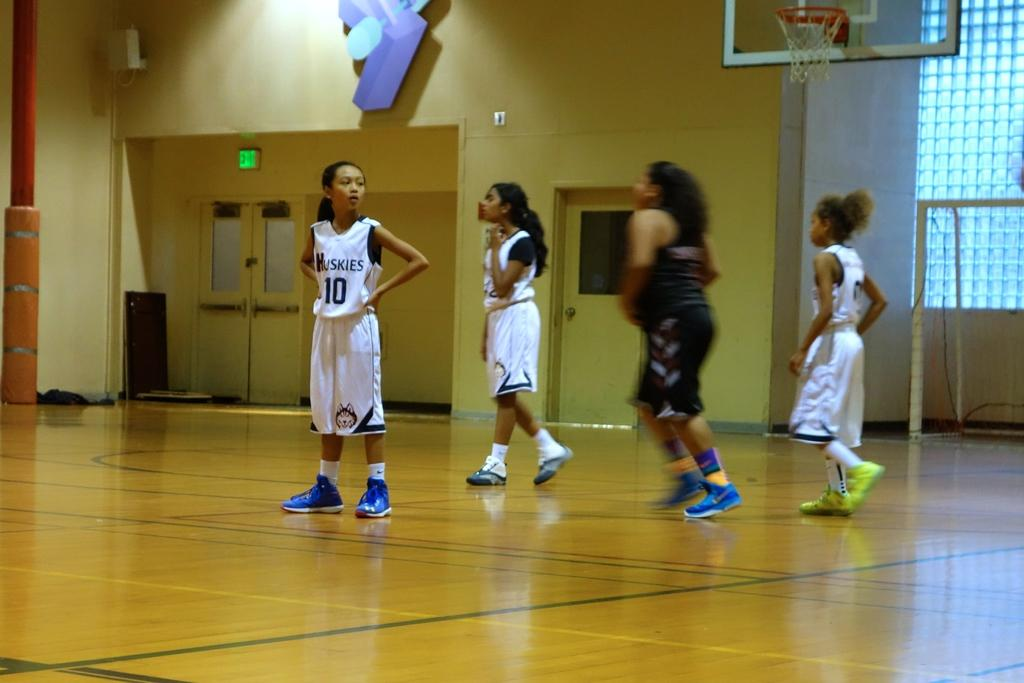How many people are present in the image? There are four people in the image. What are the people doing in the image? The people are on the floor. What can be seen in the background of the image? There is a wall and doors in the image. What sports equipment is visible in the image? A basketball hoop is visible in the image. What other objects can be seen in the image? There are some objects in the image. What type of vessel is being used to navigate the waters in the image? There is no vessel or water present in the image; it features four people on the floor, a wall, doors, and a basketball hoop. 